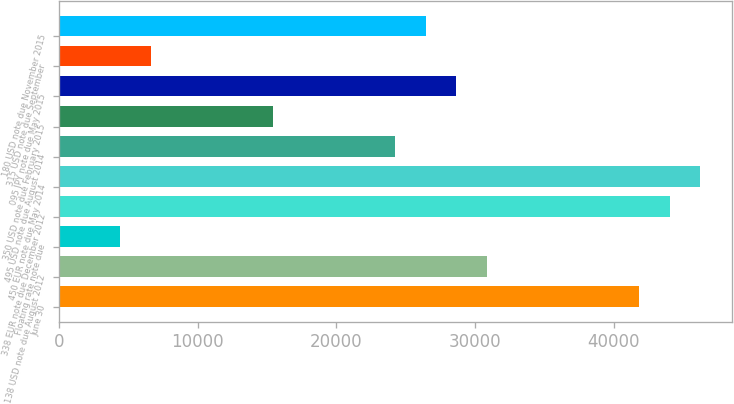Convert chart. <chart><loc_0><loc_0><loc_500><loc_500><bar_chart><fcel>June 30<fcel>138 USD note due August 2012<fcel>Floating rate note due<fcel>338 EUR note due December 2012<fcel>450 EUR note due May 2014<fcel>495 USD note due August 2014<fcel>350 USD note due February 2015<fcel>095 JPY note due May 2015<fcel>315 USD note due September<fcel>180 USD note due November 2015<nl><fcel>41859.6<fcel>30844.8<fcel>4409.32<fcel>44062.6<fcel>46265.6<fcel>24236<fcel>15424.1<fcel>28641.9<fcel>6612.28<fcel>26438.9<nl></chart> 